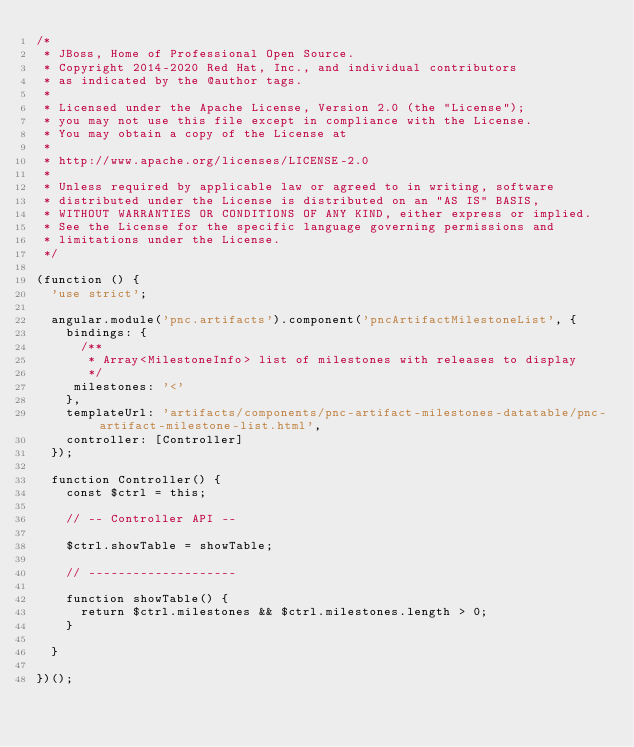Convert code to text. <code><loc_0><loc_0><loc_500><loc_500><_JavaScript_>/*
 * JBoss, Home of Professional Open Source.
 * Copyright 2014-2020 Red Hat, Inc., and individual contributors
 * as indicated by the @author tags.
 *
 * Licensed under the Apache License, Version 2.0 (the "License");
 * you may not use this file except in compliance with the License.
 * You may obtain a copy of the License at
 *
 * http://www.apache.org/licenses/LICENSE-2.0
 *
 * Unless required by applicable law or agreed to in writing, software
 * distributed under the License is distributed on an "AS IS" BASIS,
 * WITHOUT WARRANTIES OR CONDITIONS OF ANY KIND, either express or implied.
 * See the License for the specific language governing permissions and
 * limitations under the License.
 */

(function () {
  'use strict';

  angular.module('pnc.artifacts').component('pncArtifactMilestoneList', {
    bindings: {
      /**
       * Array<MilestoneInfo> list of milestones with releases to display
       */
     milestones: '<'
    },
    templateUrl: 'artifacts/components/pnc-artifact-milestones-datatable/pnc-artifact-milestone-list.html',
    controller: [Controller]
  });

  function Controller() {
    const $ctrl = this;

    // -- Controller API --

    $ctrl.showTable = showTable;

    // --------------------

    function showTable() {
      return $ctrl.milestones && $ctrl.milestones.length > 0;
    }

  }

})();
</code> 